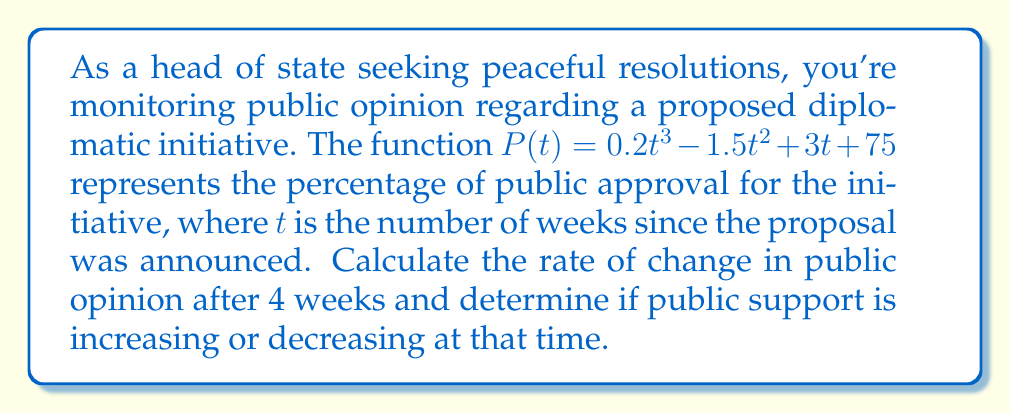What is the answer to this math problem? To solve this problem, we need to follow these steps:

1) The rate of change in public opinion is represented by the derivative of the function $P(t)$. Let's call this derivative $P'(t)$.

2) To find $P'(t)$, we apply the power rule of differentiation:
   $$P'(t) = \frac{d}{dt}(0.2t^3 - 1.5t^2 + 3t + 75)$$
   $$P'(t) = 0.6t^2 - 3t + 3$$

3) Now that we have the rate of change function, we need to evaluate it at $t = 4$ weeks:
   $$P'(4) = 0.6(4)^2 - 3(4) + 3$$
   $$P'(4) = 0.6(16) - 12 + 3$$
   $$P'(4) = 9.6 - 12 + 3$$
   $$P'(4) = 0.6$$

4) To determine if public support is increasing or decreasing, we look at the sign of $P'(4)$:
   - If $P'(4) > 0$, public support is increasing
   - If $P'(4) < 0$, public support is decreasing
   - If $P'(4) = 0$, public support is neither increasing nor decreasing (at a stationary point)

   Since $P'(4) = 0.6 > 0$, public support is increasing at 4 weeks.
Answer: The rate of change in public opinion after 4 weeks is 0.6% per week, and public support is increasing at that time. 